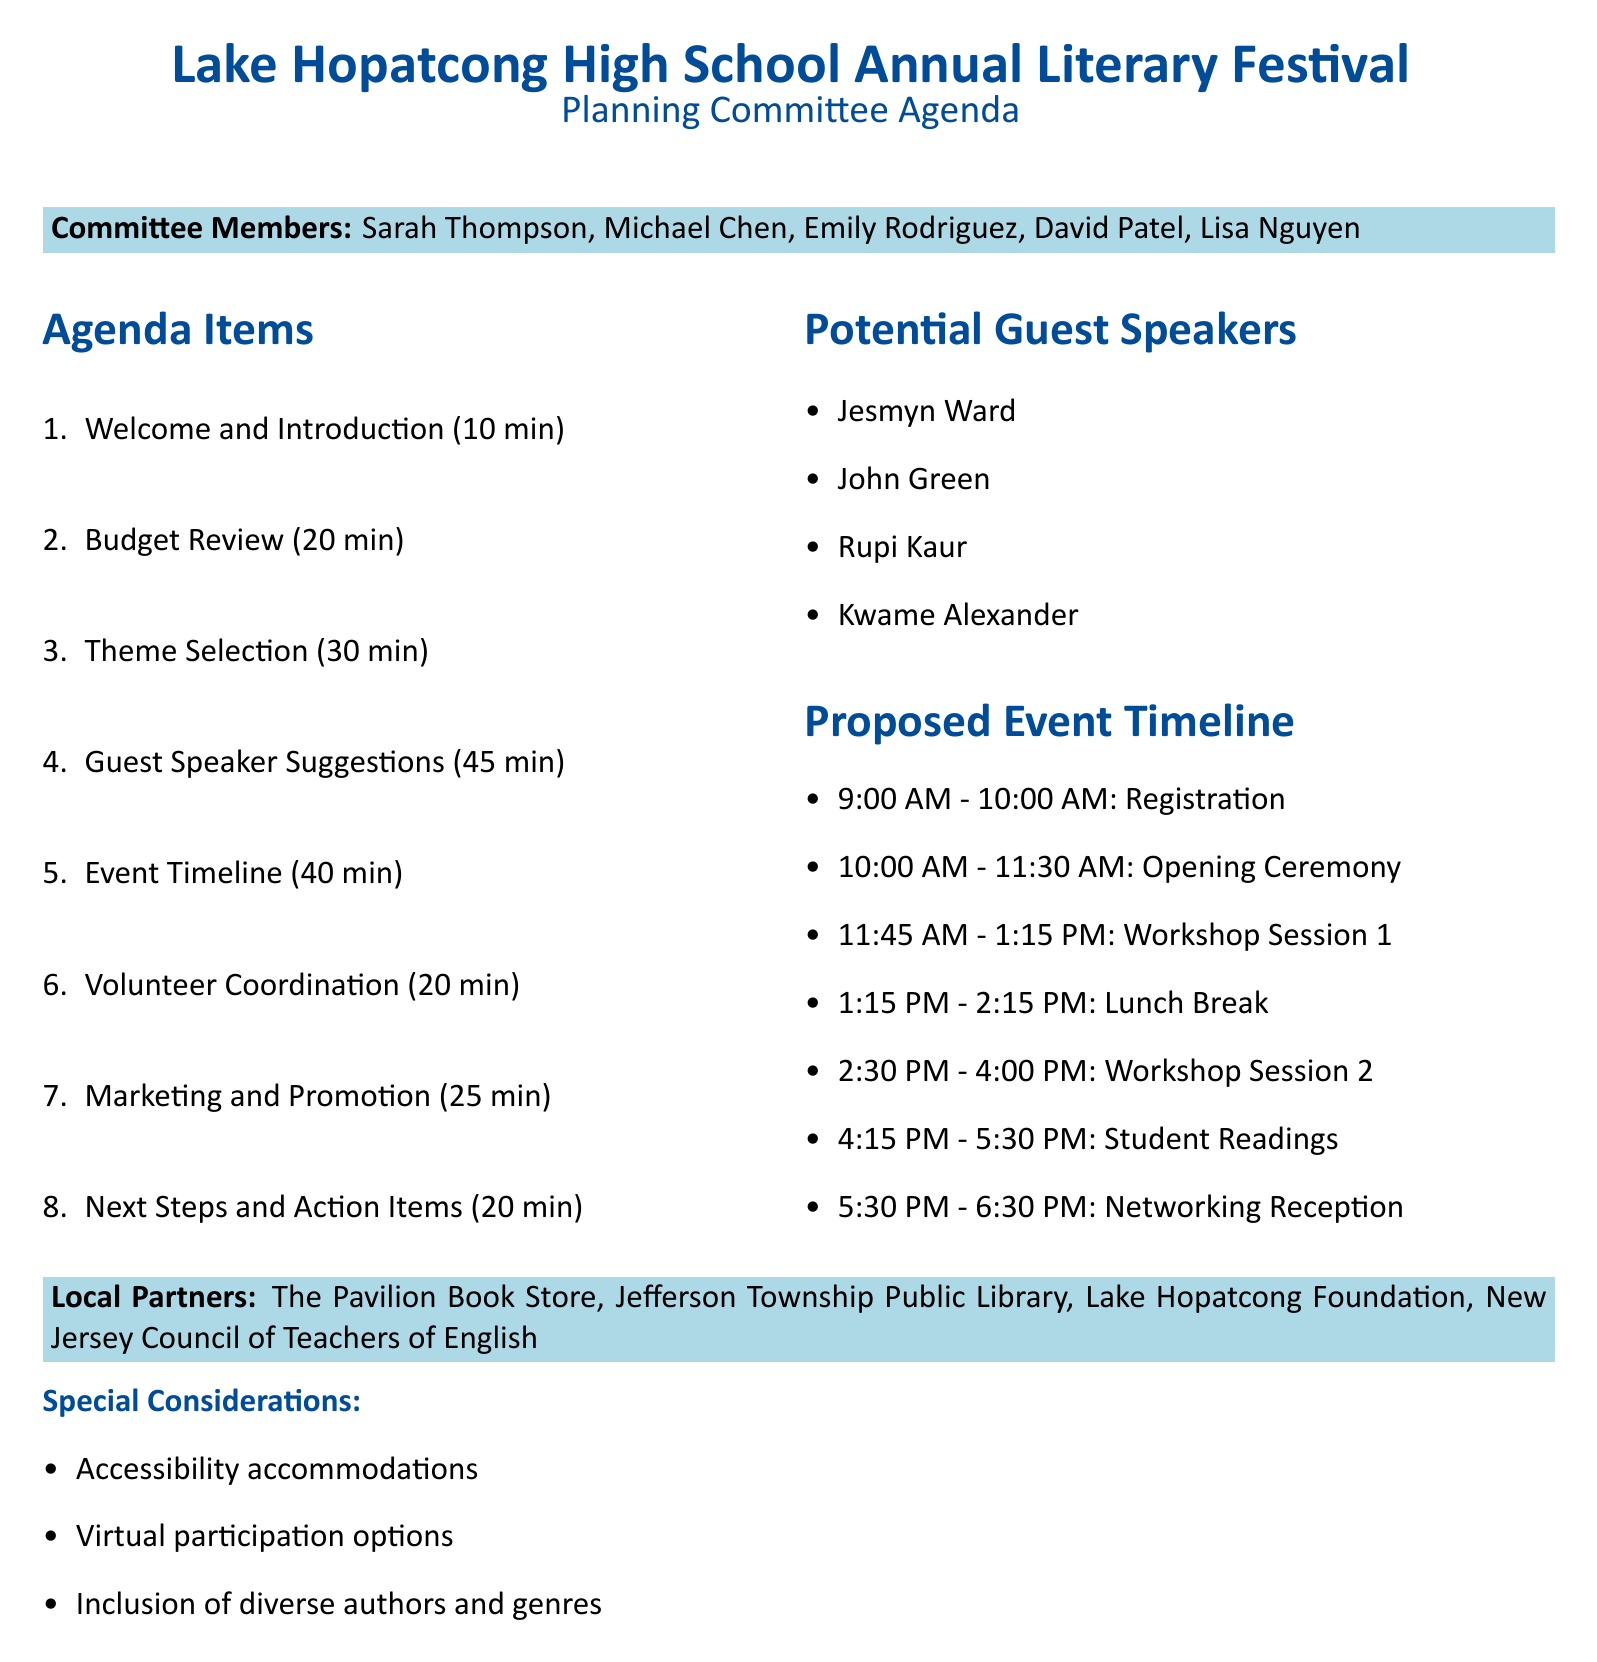What is the event name? The event name is provided at the top of the document and indicates the occasion being discussed.
Answer: Lake Hopatcong High School Annual Literary Festival Who is the chairperson of the planning committee? The document lists the members of the planning committee, highlighting who leads it.
Answer: Sarah Thompson How long is the Guest Speaker Suggestions discussion scheduled for? This information comes from the agenda items and specifies the time allocated for this particular topic.
Answer: 45 minutes What is one of the proposed themes for this year's festival? The document describes the theme selection and provides examples of themes that the committee will consider.
Answer: Voices of the Future At what time does the registration start on the event day? The proposed event timeline lists all scheduled activities, including their start times for clarity.
Answer: 9:00 AM Who is one of the potential guest speakers mentioned? The document contains a list of suggested speakers that highlights authors relevant to the festival's themes.
Answer: John Green What local partner is mentioned in the document? The local partners section of the document specifies organizations that will cooperate with the school for this festival.
Answer: The Pavilion Book Store How long is the total duration of the Volunteer Coordination agenda item? This information is found in the agenda items and clarifies the time allotted for this particular discussion.
Answer: 20 minutes What special consideration is indicated for student participation? The document includes a section addressing key considerations that ensure inclusivity and accessibility for all students.
Answer: Accessibility accommodations 